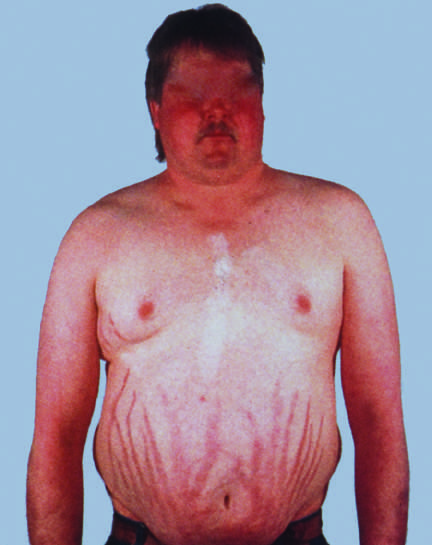do the segregation of b cells and t cells in different regions of the lymph node include central obesity, moon facies, and abdominal striae?
Answer the question using a single word or phrase. No 